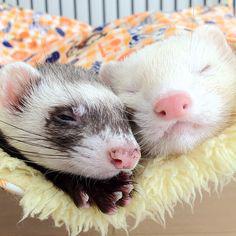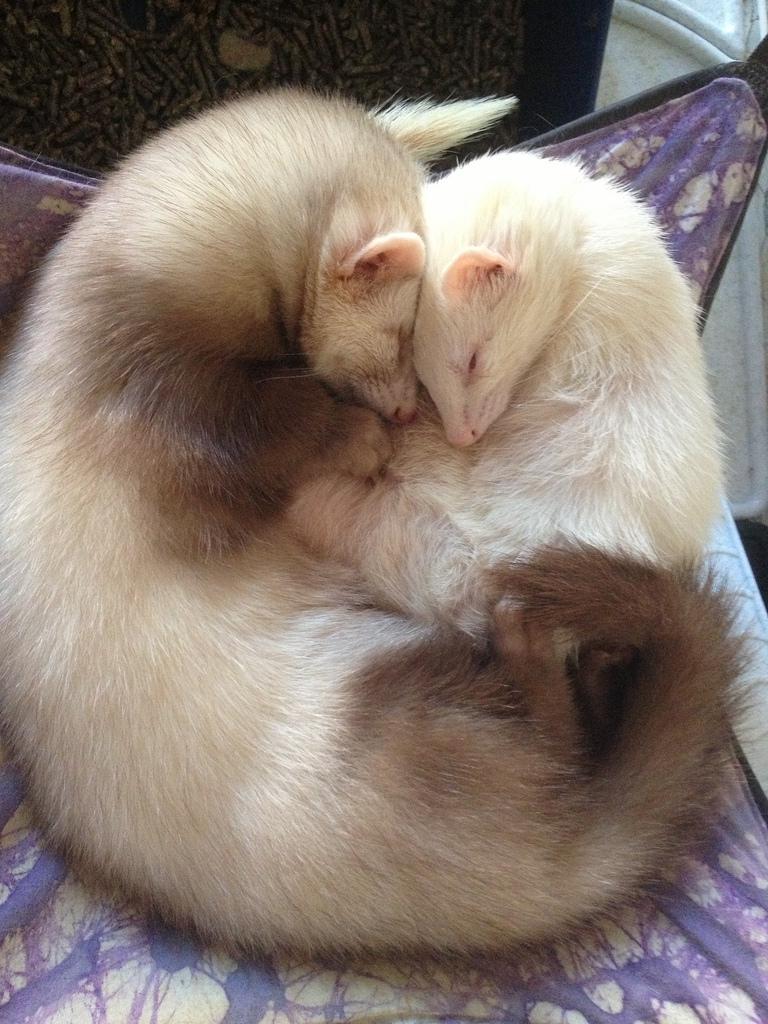The first image is the image on the left, the second image is the image on the right. For the images displayed, is the sentence "In the left image, there are two ferrets." factually correct? Answer yes or no. Yes. The first image is the image on the left, the second image is the image on the right. Considering the images on both sides, is "There are ferrets cuddling with other species of animals." valid? Answer yes or no. No. 